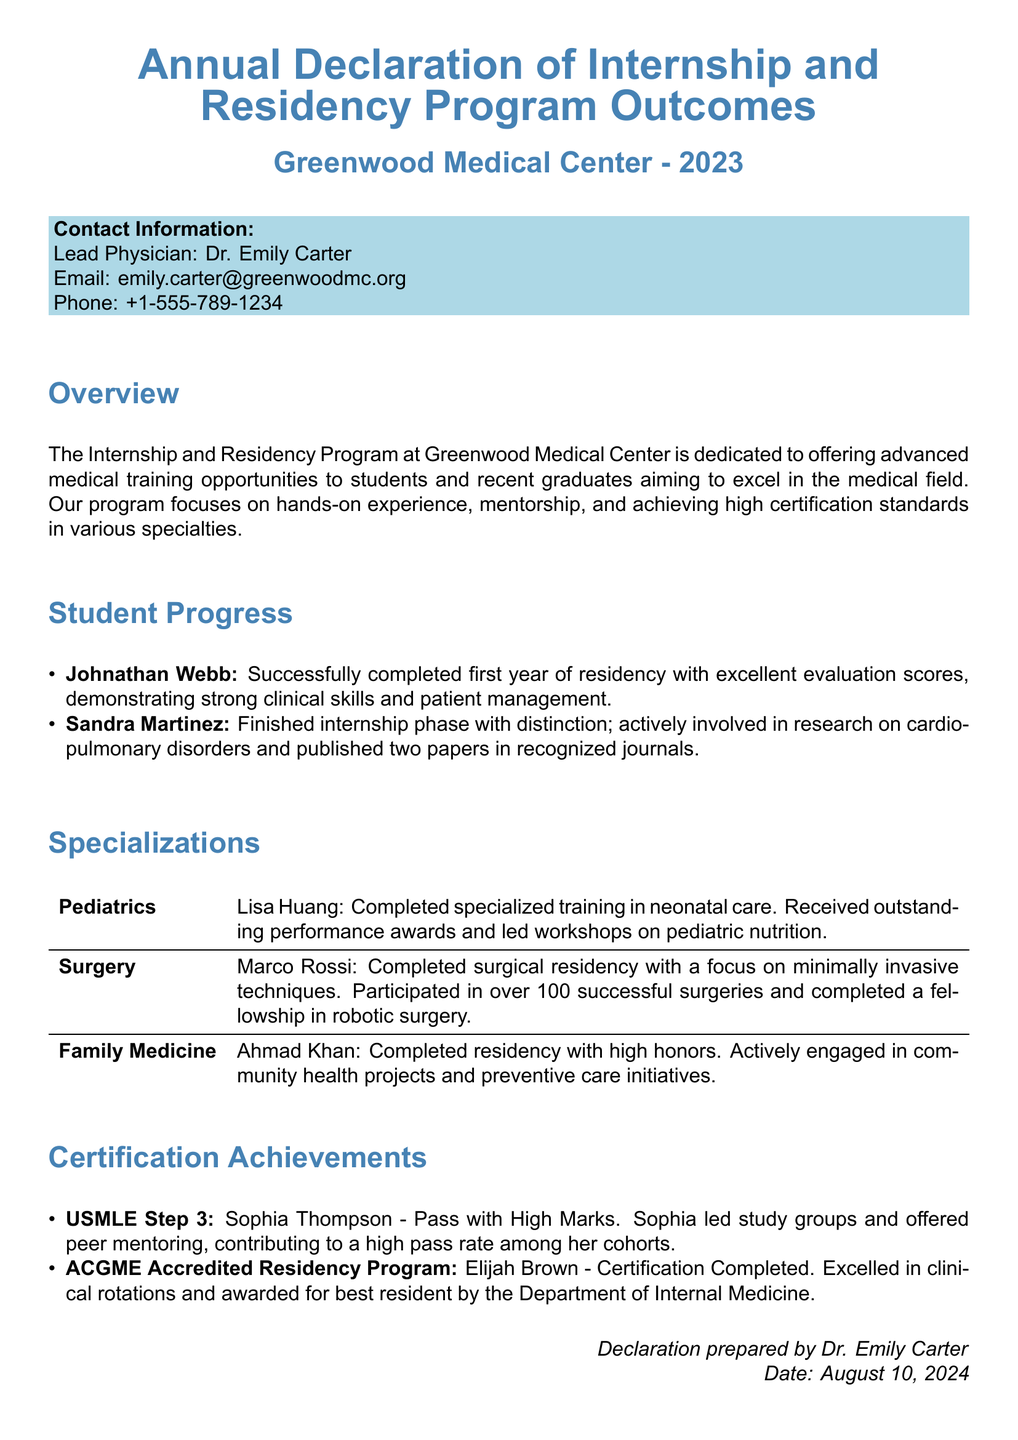What is the name of the lead physician? The lead physician is mentioned in the contact information section of the document.
Answer: Dr. Emily Carter How many successful surgeries did Marco Rossi participate in? The document states Marco Rossi's involvement in surgeries in the specializations section.
Answer: Over 100 What specialty did Ahmad Khan complete his residency in? The specialization section lists various specialties and the residents associated with them.
Answer: Family Medicine What certification did Elijah Brown achieve? This information is found in the certification achievements section discussing Elijah Brown's accomplishments.
Answer: ACGME Accredited Residency Program Who published two papers in recognized journals? The student progress section highlights contributions made by specific students.
Answer: Sandra Martinez Which student led study groups for the USMLE Step 3? The certification achievements section specifies details about students and their efforts related to certification exams.
Answer: Sophia Thompson What award did Marco Rossi receive during his surgical residency? The specialization section discusses the accomplishments of Marco Rossi in detail.
Answer: Outstanding performance awards What type of program is the Internship and Residency Program at Greenwood Medical Center? The overview section provides insight into the nature of the program.
Answer: Advanced medical training opportunities 